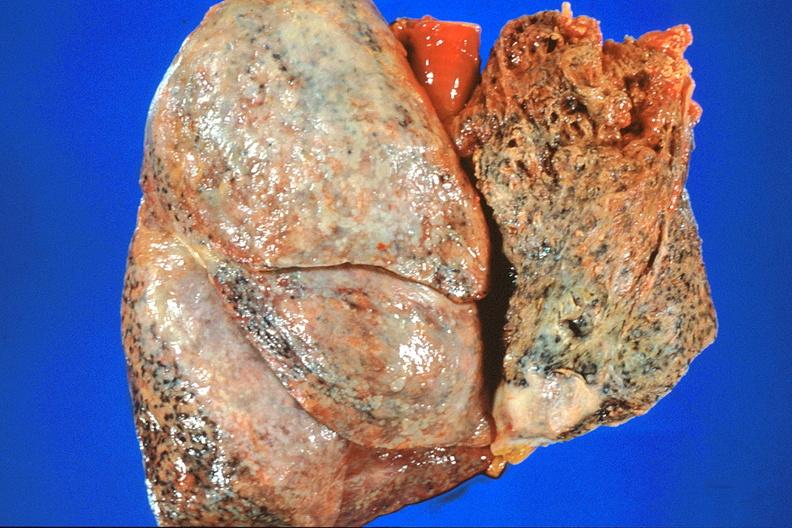does this image show lung, asbestosis and mesothelioma?
Answer the question using a single word or phrase. Yes 